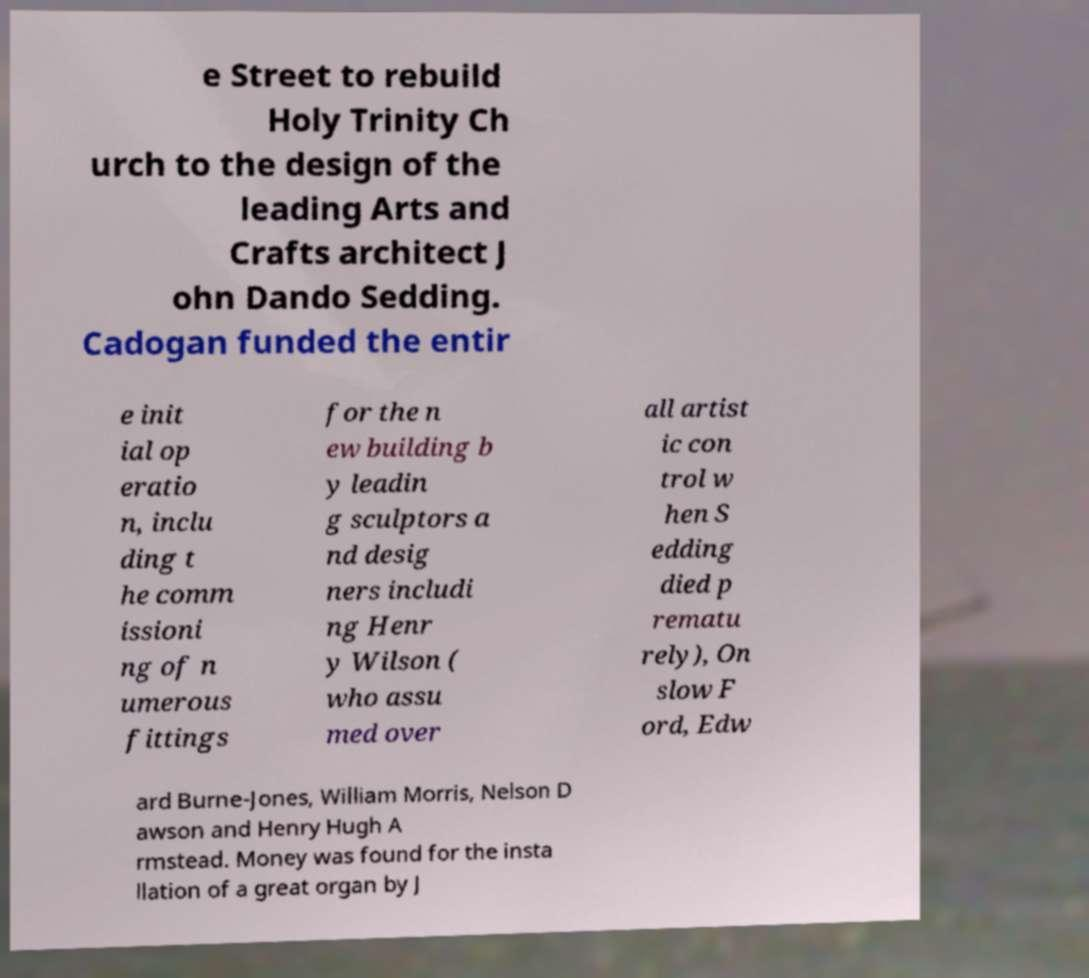There's text embedded in this image that I need extracted. Can you transcribe it verbatim? e Street to rebuild Holy Trinity Ch urch to the design of the leading Arts and Crafts architect J ohn Dando Sedding. Cadogan funded the entir e init ial op eratio n, inclu ding t he comm issioni ng of n umerous fittings for the n ew building b y leadin g sculptors a nd desig ners includi ng Henr y Wilson ( who assu med over all artist ic con trol w hen S edding died p rematu rely), On slow F ord, Edw ard Burne-Jones, William Morris, Nelson D awson and Henry Hugh A rmstead. Money was found for the insta llation of a great organ by J 